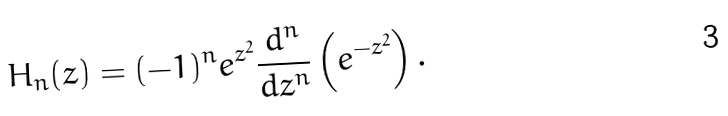<formula> <loc_0><loc_0><loc_500><loc_500>H _ { n } ( z ) = ( - 1 ) ^ { n } e ^ { z ^ { 2 } } { \frac { d ^ { n } } { d z ^ { n } } } \left ( e ^ { - z ^ { 2 } } \right ) .</formula> 